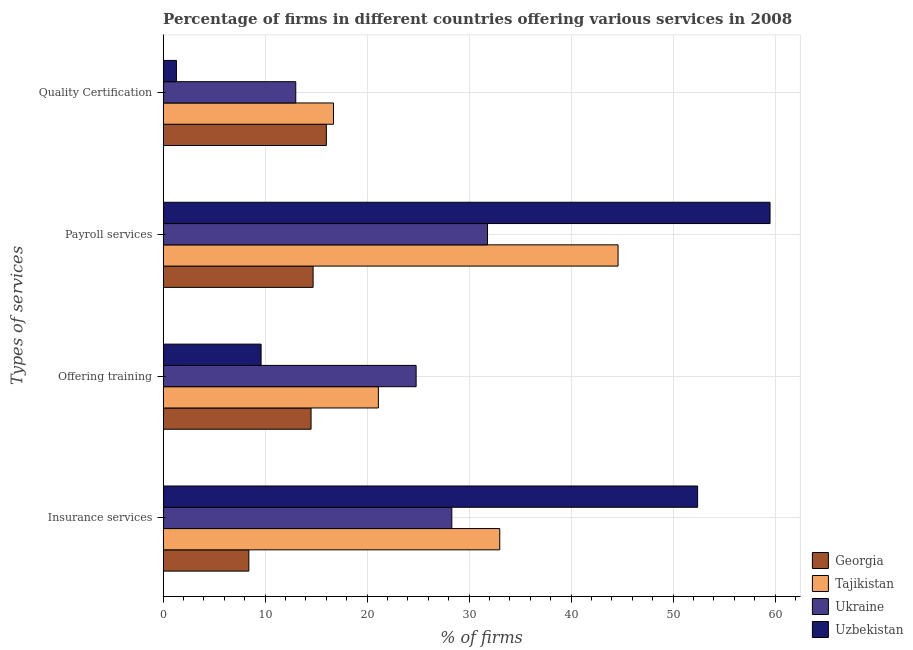How many groups of bars are there?
Keep it short and to the point. 4. What is the label of the 2nd group of bars from the top?
Your response must be concise. Payroll services. What is the percentage of firms offering training in Ukraine?
Offer a very short reply. 24.8. Across all countries, what is the maximum percentage of firms offering insurance services?
Offer a terse response. 52.4. Across all countries, what is the minimum percentage of firms offering quality certification?
Your answer should be compact. 1.3. In which country was the percentage of firms offering quality certification maximum?
Your response must be concise. Tajikistan. In which country was the percentage of firms offering insurance services minimum?
Offer a very short reply. Georgia. What is the total percentage of firms offering training in the graph?
Offer a terse response. 70. What is the difference between the percentage of firms offering training in Ukraine and that in Uzbekistan?
Provide a succinct answer. 15.2. What is the difference between the percentage of firms offering training in Tajikistan and the percentage of firms offering quality certification in Ukraine?
Your answer should be compact. 8.1. What is the average percentage of firms offering quality certification per country?
Provide a succinct answer. 11.75. What is the difference between the percentage of firms offering payroll services and percentage of firms offering insurance services in Georgia?
Keep it short and to the point. 6.3. In how many countries, is the percentage of firms offering insurance services greater than 46 %?
Give a very brief answer. 1. What is the ratio of the percentage of firms offering quality certification in Tajikistan to that in Georgia?
Your answer should be compact. 1.04. Is the difference between the percentage of firms offering payroll services in Georgia and Uzbekistan greater than the difference between the percentage of firms offering quality certification in Georgia and Uzbekistan?
Make the answer very short. No. What is the difference between the highest and the second highest percentage of firms offering training?
Provide a short and direct response. 3.7. What is the difference between the highest and the lowest percentage of firms offering payroll services?
Provide a short and direct response. 44.8. In how many countries, is the percentage of firms offering quality certification greater than the average percentage of firms offering quality certification taken over all countries?
Your answer should be very brief. 3. What does the 3rd bar from the top in Insurance services represents?
Offer a very short reply. Tajikistan. What does the 2nd bar from the bottom in Quality Certification represents?
Offer a terse response. Tajikistan. Is it the case that in every country, the sum of the percentage of firms offering insurance services and percentage of firms offering training is greater than the percentage of firms offering payroll services?
Make the answer very short. Yes. How many bars are there?
Provide a succinct answer. 16. Are the values on the major ticks of X-axis written in scientific E-notation?
Keep it short and to the point. No. Does the graph contain any zero values?
Provide a short and direct response. No. What is the title of the graph?
Your response must be concise. Percentage of firms in different countries offering various services in 2008. What is the label or title of the X-axis?
Offer a terse response. % of firms. What is the label or title of the Y-axis?
Provide a succinct answer. Types of services. What is the % of firms of Tajikistan in Insurance services?
Ensure brevity in your answer.  33. What is the % of firms of Ukraine in Insurance services?
Give a very brief answer. 28.3. What is the % of firms in Uzbekistan in Insurance services?
Offer a very short reply. 52.4. What is the % of firms in Georgia in Offering training?
Give a very brief answer. 14.5. What is the % of firms in Tajikistan in Offering training?
Your answer should be very brief. 21.1. What is the % of firms of Ukraine in Offering training?
Your answer should be very brief. 24.8. What is the % of firms in Georgia in Payroll services?
Ensure brevity in your answer.  14.7. What is the % of firms of Tajikistan in Payroll services?
Give a very brief answer. 44.6. What is the % of firms in Ukraine in Payroll services?
Your response must be concise. 31.8. What is the % of firms of Uzbekistan in Payroll services?
Provide a short and direct response. 59.5. What is the % of firms in Georgia in Quality Certification?
Your response must be concise. 16. What is the % of firms in Tajikistan in Quality Certification?
Ensure brevity in your answer.  16.7. What is the % of firms in Ukraine in Quality Certification?
Ensure brevity in your answer.  13. What is the % of firms of Uzbekistan in Quality Certification?
Your answer should be compact. 1.3. Across all Types of services, what is the maximum % of firms of Tajikistan?
Keep it short and to the point. 44.6. Across all Types of services, what is the maximum % of firms of Ukraine?
Make the answer very short. 31.8. Across all Types of services, what is the maximum % of firms in Uzbekistan?
Provide a succinct answer. 59.5. Across all Types of services, what is the minimum % of firms in Uzbekistan?
Your response must be concise. 1.3. What is the total % of firms of Georgia in the graph?
Make the answer very short. 53.6. What is the total % of firms of Tajikistan in the graph?
Keep it short and to the point. 115.4. What is the total % of firms of Ukraine in the graph?
Offer a very short reply. 97.9. What is the total % of firms in Uzbekistan in the graph?
Keep it short and to the point. 122.8. What is the difference between the % of firms of Georgia in Insurance services and that in Offering training?
Your answer should be compact. -6.1. What is the difference between the % of firms in Uzbekistan in Insurance services and that in Offering training?
Keep it short and to the point. 42.8. What is the difference between the % of firms in Tajikistan in Insurance services and that in Payroll services?
Ensure brevity in your answer.  -11.6. What is the difference between the % of firms in Ukraine in Insurance services and that in Payroll services?
Give a very brief answer. -3.5. What is the difference between the % of firms in Uzbekistan in Insurance services and that in Payroll services?
Give a very brief answer. -7.1. What is the difference between the % of firms of Uzbekistan in Insurance services and that in Quality Certification?
Give a very brief answer. 51.1. What is the difference between the % of firms of Tajikistan in Offering training and that in Payroll services?
Your answer should be compact. -23.5. What is the difference between the % of firms in Uzbekistan in Offering training and that in Payroll services?
Provide a short and direct response. -49.9. What is the difference between the % of firms of Tajikistan in Offering training and that in Quality Certification?
Your answer should be very brief. 4.4. What is the difference between the % of firms in Ukraine in Offering training and that in Quality Certification?
Provide a short and direct response. 11.8. What is the difference between the % of firms in Uzbekistan in Offering training and that in Quality Certification?
Provide a succinct answer. 8.3. What is the difference between the % of firms of Georgia in Payroll services and that in Quality Certification?
Your answer should be very brief. -1.3. What is the difference between the % of firms of Tajikistan in Payroll services and that in Quality Certification?
Keep it short and to the point. 27.9. What is the difference between the % of firms in Ukraine in Payroll services and that in Quality Certification?
Ensure brevity in your answer.  18.8. What is the difference between the % of firms in Uzbekistan in Payroll services and that in Quality Certification?
Offer a very short reply. 58.2. What is the difference between the % of firms of Georgia in Insurance services and the % of firms of Tajikistan in Offering training?
Your answer should be very brief. -12.7. What is the difference between the % of firms in Georgia in Insurance services and the % of firms in Ukraine in Offering training?
Offer a very short reply. -16.4. What is the difference between the % of firms of Tajikistan in Insurance services and the % of firms of Uzbekistan in Offering training?
Your response must be concise. 23.4. What is the difference between the % of firms in Georgia in Insurance services and the % of firms in Tajikistan in Payroll services?
Offer a very short reply. -36.2. What is the difference between the % of firms in Georgia in Insurance services and the % of firms in Ukraine in Payroll services?
Ensure brevity in your answer.  -23.4. What is the difference between the % of firms in Georgia in Insurance services and the % of firms in Uzbekistan in Payroll services?
Offer a terse response. -51.1. What is the difference between the % of firms of Tajikistan in Insurance services and the % of firms of Uzbekistan in Payroll services?
Offer a terse response. -26.5. What is the difference between the % of firms of Ukraine in Insurance services and the % of firms of Uzbekistan in Payroll services?
Keep it short and to the point. -31.2. What is the difference between the % of firms in Georgia in Insurance services and the % of firms in Tajikistan in Quality Certification?
Make the answer very short. -8.3. What is the difference between the % of firms of Georgia in Insurance services and the % of firms of Ukraine in Quality Certification?
Provide a succinct answer. -4.6. What is the difference between the % of firms of Georgia in Insurance services and the % of firms of Uzbekistan in Quality Certification?
Your response must be concise. 7.1. What is the difference between the % of firms of Tajikistan in Insurance services and the % of firms of Uzbekistan in Quality Certification?
Offer a very short reply. 31.7. What is the difference between the % of firms in Georgia in Offering training and the % of firms in Tajikistan in Payroll services?
Provide a short and direct response. -30.1. What is the difference between the % of firms in Georgia in Offering training and the % of firms in Ukraine in Payroll services?
Offer a very short reply. -17.3. What is the difference between the % of firms of Georgia in Offering training and the % of firms of Uzbekistan in Payroll services?
Ensure brevity in your answer.  -45. What is the difference between the % of firms of Tajikistan in Offering training and the % of firms of Ukraine in Payroll services?
Your response must be concise. -10.7. What is the difference between the % of firms of Tajikistan in Offering training and the % of firms of Uzbekistan in Payroll services?
Provide a succinct answer. -38.4. What is the difference between the % of firms of Ukraine in Offering training and the % of firms of Uzbekistan in Payroll services?
Offer a terse response. -34.7. What is the difference between the % of firms in Tajikistan in Offering training and the % of firms in Ukraine in Quality Certification?
Give a very brief answer. 8.1. What is the difference between the % of firms of Tajikistan in Offering training and the % of firms of Uzbekistan in Quality Certification?
Give a very brief answer. 19.8. What is the difference between the % of firms in Ukraine in Offering training and the % of firms in Uzbekistan in Quality Certification?
Offer a terse response. 23.5. What is the difference between the % of firms of Tajikistan in Payroll services and the % of firms of Ukraine in Quality Certification?
Your answer should be compact. 31.6. What is the difference between the % of firms of Tajikistan in Payroll services and the % of firms of Uzbekistan in Quality Certification?
Your response must be concise. 43.3. What is the difference between the % of firms of Ukraine in Payroll services and the % of firms of Uzbekistan in Quality Certification?
Offer a very short reply. 30.5. What is the average % of firms of Georgia per Types of services?
Your answer should be compact. 13.4. What is the average % of firms in Tajikistan per Types of services?
Offer a terse response. 28.85. What is the average % of firms of Ukraine per Types of services?
Make the answer very short. 24.48. What is the average % of firms in Uzbekistan per Types of services?
Ensure brevity in your answer.  30.7. What is the difference between the % of firms of Georgia and % of firms of Tajikistan in Insurance services?
Provide a short and direct response. -24.6. What is the difference between the % of firms in Georgia and % of firms in Ukraine in Insurance services?
Your answer should be compact. -19.9. What is the difference between the % of firms in Georgia and % of firms in Uzbekistan in Insurance services?
Ensure brevity in your answer.  -44. What is the difference between the % of firms of Tajikistan and % of firms of Ukraine in Insurance services?
Provide a short and direct response. 4.7. What is the difference between the % of firms of Tajikistan and % of firms of Uzbekistan in Insurance services?
Give a very brief answer. -19.4. What is the difference between the % of firms of Ukraine and % of firms of Uzbekistan in Insurance services?
Ensure brevity in your answer.  -24.1. What is the difference between the % of firms of Georgia and % of firms of Ukraine in Offering training?
Offer a very short reply. -10.3. What is the difference between the % of firms of Tajikistan and % of firms of Uzbekistan in Offering training?
Provide a short and direct response. 11.5. What is the difference between the % of firms in Georgia and % of firms in Tajikistan in Payroll services?
Provide a succinct answer. -29.9. What is the difference between the % of firms in Georgia and % of firms in Ukraine in Payroll services?
Ensure brevity in your answer.  -17.1. What is the difference between the % of firms in Georgia and % of firms in Uzbekistan in Payroll services?
Provide a succinct answer. -44.8. What is the difference between the % of firms in Tajikistan and % of firms in Ukraine in Payroll services?
Keep it short and to the point. 12.8. What is the difference between the % of firms of Tajikistan and % of firms of Uzbekistan in Payroll services?
Your response must be concise. -14.9. What is the difference between the % of firms in Ukraine and % of firms in Uzbekistan in Payroll services?
Offer a terse response. -27.7. What is the difference between the % of firms in Georgia and % of firms in Tajikistan in Quality Certification?
Keep it short and to the point. -0.7. What is the difference between the % of firms of Georgia and % of firms of Uzbekistan in Quality Certification?
Offer a very short reply. 14.7. What is the difference between the % of firms in Tajikistan and % of firms in Ukraine in Quality Certification?
Give a very brief answer. 3.7. What is the difference between the % of firms in Ukraine and % of firms in Uzbekistan in Quality Certification?
Make the answer very short. 11.7. What is the ratio of the % of firms in Georgia in Insurance services to that in Offering training?
Make the answer very short. 0.58. What is the ratio of the % of firms of Tajikistan in Insurance services to that in Offering training?
Give a very brief answer. 1.56. What is the ratio of the % of firms in Ukraine in Insurance services to that in Offering training?
Your answer should be very brief. 1.14. What is the ratio of the % of firms in Uzbekistan in Insurance services to that in Offering training?
Provide a short and direct response. 5.46. What is the ratio of the % of firms in Tajikistan in Insurance services to that in Payroll services?
Offer a very short reply. 0.74. What is the ratio of the % of firms in Ukraine in Insurance services to that in Payroll services?
Provide a succinct answer. 0.89. What is the ratio of the % of firms in Uzbekistan in Insurance services to that in Payroll services?
Give a very brief answer. 0.88. What is the ratio of the % of firms in Georgia in Insurance services to that in Quality Certification?
Your answer should be compact. 0.53. What is the ratio of the % of firms in Tajikistan in Insurance services to that in Quality Certification?
Your answer should be compact. 1.98. What is the ratio of the % of firms in Ukraine in Insurance services to that in Quality Certification?
Offer a very short reply. 2.18. What is the ratio of the % of firms of Uzbekistan in Insurance services to that in Quality Certification?
Provide a succinct answer. 40.31. What is the ratio of the % of firms in Georgia in Offering training to that in Payroll services?
Your answer should be compact. 0.99. What is the ratio of the % of firms in Tajikistan in Offering training to that in Payroll services?
Your response must be concise. 0.47. What is the ratio of the % of firms of Ukraine in Offering training to that in Payroll services?
Your answer should be very brief. 0.78. What is the ratio of the % of firms of Uzbekistan in Offering training to that in Payroll services?
Your answer should be very brief. 0.16. What is the ratio of the % of firms of Georgia in Offering training to that in Quality Certification?
Offer a terse response. 0.91. What is the ratio of the % of firms in Tajikistan in Offering training to that in Quality Certification?
Give a very brief answer. 1.26. What is the ratio of the % of firms of Ukraine in Offering training to that in Quality Certification?
Your answer should be very brief. 1.91. What is the ratio of the % of firms of Uzbekistan in Offering training to that in Quality Certification?
Offer a terse response. 7.38. What is the ratio of the % of firms in Georgia in Payroll services to that in Quality Certification?
Offer a very short reply. 0.92. What is the ratio of the % of firms in Tajikistan in Payroll services to that in Quality Certification?
Give a very brief answer. 2.67. What is the ratio of the % of firms of Ukraine in Payroll services to that in Quality Certification?
Give a very brief answer. 2.45. What is the ratio of the % of firms of Uzbekistan in Payroll services to that in Quality Certification?
Your answer should be compact. 45.77. What is the difference between the highest and the second highest % of firms in Georgia?
Offer a terse response. 1.3. What is the difference between the highest and the second highest % of firms in Ukraine?
Provide a short and direct response. 3.5. What is the difference between the highest and the second highest % of firms in Uzbekistan?
Ensure brevity in your answer.  7.1. What is the difference between the highest and the lowest % of firms of Georgia?
Your answer should be compact. 7.6. What is the difference between the highest and the lowest % of firms of Tajikistan?
Offer a very short reply. 27.9. What is the difference between the highest and the lowest % of firms in Uzbekistan?
Your response must be concise. 58.2. 